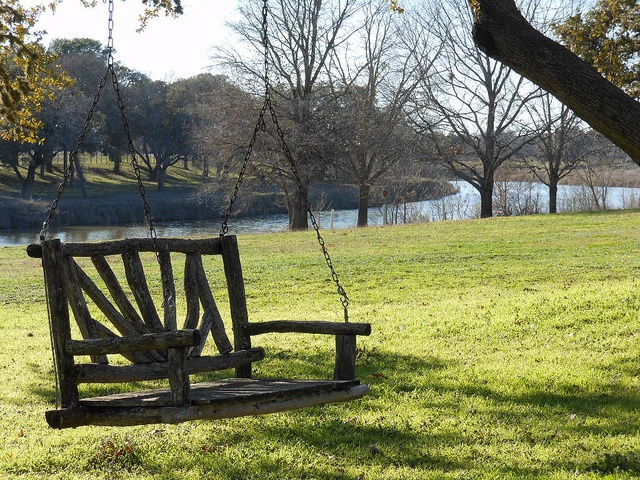Describe the objects in this image and their specific colors. I can see a bench in gray, black, olive, darkgreen, and khaki tones in this image. 